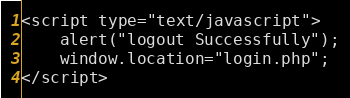Convert code to text. <code><loc_0><loc_0><loc_500><loc_500><_PHP_><script type="text/javascript">
	alert("logout Successfully");
	window.location="login.php";
</script></code> 